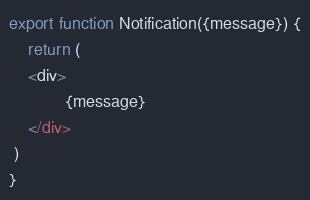<code> <loc_0><loc_0><loc_500><loc_500><_JavaScript_>export function Notification({message}) {
    return (
    <div>
            {message}
    </div>
 )
}</code> 